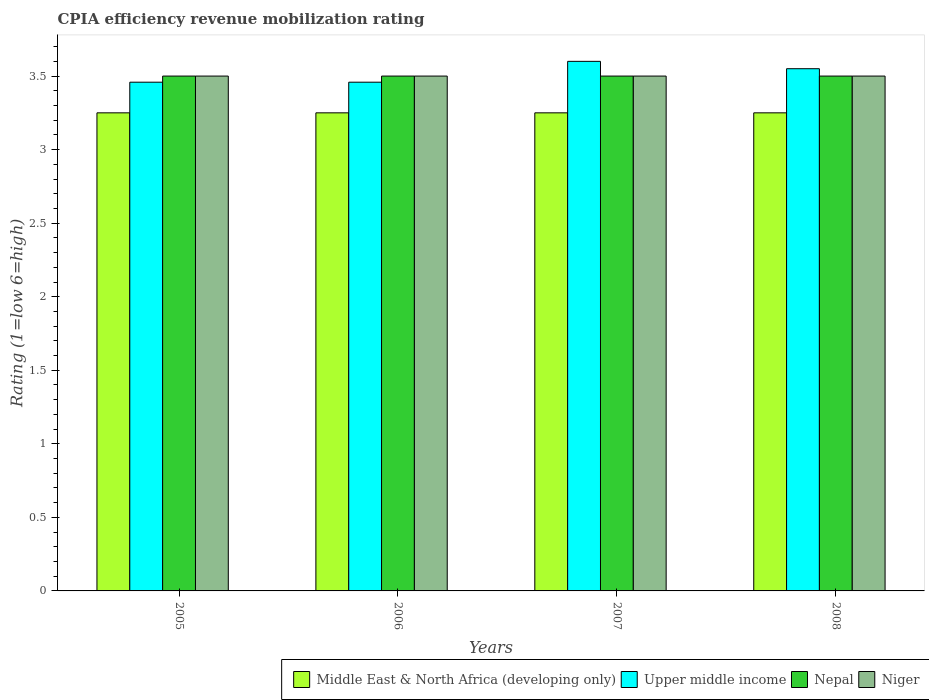How many different coloured bars are there?
Keep it short and to the point. 4. How many groups of bars are there?
Keep it short and to the point. 4. How many bars are there on the 3rd tick from the right?
Provide a short and direct response. 4. In how many cases, is the number of bars for a given year not equal to the number of legend labels?
Provide a succinct answer. 0. Across all years, what is the minimum CPIA rating in Niger?
Provide a succinct answer. 3.5. In which year was the CPIA rating in Upper middle income maximum?
Give a very brief answer. 2007. In which year was the CPIA rating in Upper middle income minimum?
Provide a short and direct response. 2005. What is the total CPIA rating in Upper middle income in the graph?
Your answer should be compact. 14.07. What is the difference between the CPIA rating in Upper middle income in 2005 and that in 2008?
Ensure brevity in your answer.  -0.09. What is the difference between the CPIA rating in Upper middle income in 2008 and the CPIA rating in Nepal in 2006?
Offer a very short reply. 0.05. What is the ratio of the CPIA rating in Nepal in 2006 to that in 2008?
Your answer should be compact. 1. What is the difference between the highest and the second highest CPIA rating in Niger?
Offer a very short reply. 0. In how many years, is the CPIA rating in Upper middle income greater than the average CPIA rating in Upper middle income taken over all years?
Give a very brief answer. 2. Is the sum of the CPIA rating in Upper middle income in 2005 and 2007 greater than the maximum CPIA rating in Nepal across all years?
Ensure brevity in your answer.  Yes. Is it the case that in every year, the sum of the CPIA rating in Middle East & North Africa (developing only) and CPIA rating in Nepal is greater than the sum of CPIA rating in Upper middle income and CPIA rating in Niger?
Offer a terse response. Yes. What does the 3rd bar from the left in 2006 represents?
Your answer should be compact. Nepal. What does the 4th bar from the right in 2008 represents?
Your response must be concise. Middle East & North Africa (developing only). Is it the case that in every year, the sum of the CPIA rating in Middle East & North Africa (developing only) and CPIA rating in Nepal is greater than the CPIA rating in Upper middle income?
Provide a succinct answer. Yes. How many years are there in the graph?
Ensure brevity in your answer.  4. Are the values on the major ticks of Y-axis written in scientific E-notation?
Your answer should be very brief. No. Does the graph contain any zero values?
Your response must be concise. No. How are the legend labels stacked?
Keep it short and to the point. Horizontal. What is the title of the graph?
Your response must be concise. CPIA efficiency revenue mobilization rating. What is the label or title of the Y-axis?
Your answer should be very brief. Rating (1=low 6=high). What is the Rating (1=low 6=high) of Middle East & North Africa (developing only) in 2005?
Provide a succinct answer. 3.25. What is the Rating (1=low 6=high) in Upper middle income in 2005?
Keep it short and to the point. 3.46. What is the Rating (1=low 6=high) in Nepal in 2005?
Your answer should be compact. 3.5. What is the Rating (1=low 6=high) of Niger in 2005?
Your answer should be compact. 3.5. What is the Rating (1=low 6=high) in Middle East & North Africa (developing only) in 2006?
Keep it short and to the point. 3.25. What is the Rating (1=low 6=high) in Upper middle income in 2006?
Give a very brief answer. 3.46. What is the Rating (1=low 6=high) in Middle East & North Africa (developing only) in 2007?
Make the answer very short. 3.25. What is the Rating (1=low 6=high) in Nepal in 2007?
Offer a very short reply. 3.5. What is the Rating (1=low 6=high) in Middle East & North Africa (developing only) in 2008?
Offer a very short reply. 3.25. What is the Rating (1=low 6=high) in Upper middle income in 2008?
Keep it short and to the point. 3.55. What is the Rating (1=low 6=high) in Nepal in 2008?
Make the answer very short. 3.5. What is the Rating (1=low 6=high) of Niger in 2008?
Give a very brief answer. 3.5. Across all years, what is the maximum Rating (1=low 6=high) in Middle East & North Africa (developing only)?
Offer a very short reply. 3.25. Across all years, what is the maximum Rating (1=low 6=high) of Upper middle income?
Provide a short and direct response. 3.6. Across all years, what is the minimum Rating (1=low 6=high) in Middle East & North Africa (developing only)?
Give a very brief answer. 3.25. Across all years, what is the minimum Rating (1=low 6=high) of Upper middle income?
Your answer should be very brief. 3.46. What is the total Rating (1=low 6=high) of Middle East & North Africa (developing only) in the graph?
Provide a succinct answer. 13. What is the total Rating (1=low 6=high) of Upper middle income in the graph?
Your answer should be very brief. 14.07. What is the total Rating (1=low 6=high) of Nepal in the graph?
Ensure brevity in your answer.  14. What is the total Rating (1=low 6=high) of Niger in the graph?
Provide a short and direct response. 14. What is the difference between the Rating (1=low 6=high) of Upper middle income in 2005 and that in 2006?
Your response must be concise. 0. What is the difference between the Rating (1=low 6=high) in Niger in 2005 and that in 2006?
Provide a short and direct response. 0. What is the difference between the Rating (1=low 6=high) in Middle East & North Africa (developing only) in 2005 and that in 2007?
Your answer should be compact. 0. What is the difference between the Rating (1=low 6=high) in Upper middle income in 2005 and that in 2007?
Your answer should be very brief. -0.14. What is the difference between the Rating (1=low 6=high) in Nepal in 2005 and that in 2007?
Provide a short and direct response. 0. What is the difference between the Rating (1=low 6=high) of Niger in 2005 and that in 2007?
Ensure brevity in your answer.  0. What is the difference between the Rating (1=low 6=high) of Middle East & North Africa (developing only) in 2005 and that in 2008?
Make the answer very short. 0. What is the difference between the Rating (1=low 6=high) in Upper middle income in 2005 and that in 2008?
Your answer should be very brief. -0.09. What is the difference between the Rating (1=low 6=high) in Niger in 2005 and that in 2008?
Your answer should be very brief. 0. What is the difference between the Rating (1=low 6=high) in Upper middle income in 2006 and that in 2007?
Ensure brevity in your answer.  -0.14. What is the difference between the Rating (1=low 6=high) of Nepal in 2006 and that in 2007?
Make the answer very short. 0. What is the difference between the Rating (1=low 6=high) of Niger in 2006 and that in 2007?
Your answer should be compact. 0. What is the difference between the Rating (1=low 6=high) of Upper middle income in 2006 and that in 2008?
Keep it short and to the point. -0.09. What is the difference between the Rating (1=low 6=high) in Nepal in 2007 and that in 2008?
Offer a very short reply. 0. What is the difference between the Rating (1=low 6=high) in Niger in 2007 and that in 2008?
Offer a terse response. 0. What is the difference between the Rating (1=low 6=high) in Middle East & North Africa (developing only) in 2005 and the Rating (1=low 6=high) in Upper middle income in 2006?
Your response must be concise. -0.21. What is the difference between the Rating (1=low 6=high) in Upper middle income in 2005 and the Rating (1=low 6=high) in Nepal in 2006?
Offer a terse response. -0.04. What is the difference between the Rating (1=low 6=high) of Upper middle income in 2005 and the Rating (1=low 6=high) of Niger in 2006?
Provide a short and direct response. -0.04. What is the difference between the Rating (1=low 6=high) in Middle East & North Africa (developing only) in 2005 and the Rating (1=low 6=high) in Upper middle income in 2007?
Provide a succinct answer. -0.35. What is the difference between the Rating (1=low 6=high) in Upper middle income in 2005 and the Rating (1=low 6=high) in Nepal in 2007?
Your response must be concise. -0.04. What is the difference between the Rating (1=low 6=high) in Upper middle income in 2005 and the Rating (1=low 6=high) in Niger in 2007?
Offer a terse response. -0.04. What is the difference between the Rating (1=low 6=high) in Middle East & North Africa (developing only) in 2005 and the Rating (1=low 6=high) in Nepal in 2008?
Give a very brief answer. -0.25. What is the difference between the Rating (1=low 6=high) of Upper middle income in 2005 and the Rating (1=low 6=high) of Nepal in 2008?
Your answer should be compact. -0.04. What is the difference between the Rating (1=low 6=high) of Upper middle income in 2005 and the Rating (1=low 6=high) of Niger in 2008?
Keep it short and to the point. -0.04. What is the difference between the Rating (1=low 6=high) of Middle East & North Africa (developing only) in 2006 and the Rating (1=low 6=high) of Upper middle income in 2007?
Ensure brevity in your answer.  -0.35. What is the difference between the Rating (1=low 6=high) of Middle East & North Africa (developing only) in 2006 and the Rating (1=low 6=high) of Nepal in 2007?
Provide a short and direct response. -0.25. What is the difference between the Rating (1=low 6=high) of Upper middle income in 2006 and the Rating (1=low 6=high) of Nepal in 2007?
Make the answer very short. -0.04. What is the difference between the Rating (1=low 6=high) in Upper middle income in 2006 and the Rating (1=low 6=high) in Niger in 2007?
Ensure brevity in your answer.  -0.04. What is the difference between the Rating (1=low 6=high) of Middle East & North Africa (developing only) in 2006 and the Rating (1=low 6=high) of Niger in 2008?
Your answer should be compact. -0.25. What is the difference between the Rating (1=low 6=high) of Upper middle income in 2006 and the Rating (1=low 6=high) of Nepal in 2008?
Ensure brevity in your answer.  -0.04. What is the difference between the Rating (1=low 6=high) in Upper middle income in 2006 and the Rating (1=low 6=high) in Niger in 2008?
Keep it short and to the point. -0.04. What is the difference between the Rating (1=low 6=high) in Middle East & North Africa (developing only) in 2007 and the Rating (1=low 6=high) in Upper middle income in 2008?
Offer a terse response. -0.3. What is the difference between the Rating (1=low 6=high) of Middle East & North Africa (developing only) in 2007 and the Rating (1=low 6=high) of Nepal in 2008?
Keep it short and to the point. -0.25. What is the difference between the Rating (1=low 6=high) of Middle East & North Africa (developing only) in 2007 and the Rating (1=low 6=high) of Niger in 2008?
Your answer should be compact. -0.25. What is the difference between the Rating (1=low 6=high) in Upper middle income in 2007 and the Rating (1=low 6=high) in Nepal in 2008?
Your response must be concise. 0.1. What is the average Rating (1=low 6=high) of Middle East & North Africa (developing only) per year?
Your answer should be very brief. 3.25. What is the average Rating (1=low 6=high) of Upper middle income per year?
Offer a terse response. 3.52. What is the average Rating (1=low 6=high) of Niger per year?
Your answer should be compact. 3.5. In the year 2005, what is the difference between the Rating (1=low 6=high) in Middle East & North Africa (developing only) and Rating (1=low 6=high) in Upper middle income?
Your response must be concise. -0.21. In the year 2005, what is the difference between the Rating (1=low 6=high) of Upper middle income and Rating (1=low 6=high) of Nepal?
Offer a very short reply. -0.04. In the year 2005, what is the difference between the Rating (1=low 6=high) in Upper middle income and Rating (1=low 6=high) in Niger?
Your answer should be compact. -0.04. In the year 2005, what is the difference between the Rating (1=low 6=high) in Nepal and Rating (1=low 6=high) in Niger?
Keep it short and to the point. 0. In the year 2006, what is the difference between the Rating (1=low 6=high) in Middle East & North Africa (developing only) and Rating (1=low 6=high) in Upper middle income?
Provide a short and direct response. -0.21. In the year 2006, what is the difference between the Rating (1=low 6=high) of Middle East & North Africa (developing only) and Rating (1=low 6=high) of Nepal?
Offer a very short reply. -0.25. In the year 2006, what is the difference between the Rating (1=low 6=high) of Upper middle income and Rating (1=low 6=high) of Nepal?
Your answer should be very brief. -0.04. In the year 2006, what is the difference between the Rating (1=low 6=high) in Upper middle income and Rating (1=low 6=high) in Niger?
Ensure brevity in your answer.  -0.04. In the year 2006, what is the difference between the Rating (1=low 6=high) in Nepal and Rating (1=low 6=high) in Niger?
Offer a terse response. 0. In the year 2007, what is the difference between the Rating (1=low 6=high) in Middle East & North Africa (developing only) and Rating (1=low 6=high) in Upper middle income?
Offer a very short reply. -0.35. In the year 2007, what is the difference between the Rating (1=low 6=high) in Upper middle income and Rating (1=low 6=high) in Nepal?
Offer a very short reply. 0.1. In the year 2007, what is the difference between the Rating (1=low 6=high) of Upper middle income and Rating (1=low 6=high) of Niger?
Your answer should be very brief. 0.1. In the year 2007, what is the difference between the Rating (1=low 6=high) of Nepal and Rating (1=low 6=high) of Niger?
Make the answer very short. 0. In the year 2008, what is the difference between the Rating (1=low 6=high) of Middle East & North Africa (developing only) and Rating (1=low 6=high) of Niger?
Ensure brevity in your answer.  -0.25. In the year 2008, what is the difference between the Rating (1=low 6=high) in Upper middle income and Rating (1=low 6=high) in Nepal?
Provide a succinct answer. 0.05. In the year 2008, what is the difference between the Rating (1=low 6=high) in Nepal and Rating (1=low 6=high) in Niger?
Give a very brief answer. 0. What is the ratio of the Rating (1=low 6=high) in Middle East & North Africa (developing only) in 2005 to that in 2006?
Keep it short and to the point. 1. What is the ratio of the Rating (1=low 6=high) of Niger in 2005 to that in 2006?
Keep it short and to the point. 1. What is the ratio of the Rating (1=low 6=high) of Upper middle income in 2005 to that in 2007?
Provide a short and direct response. 0.96. What is the ratio of the Rating (1=low 6=high) of Nepal in 2005 to that in 2007?
Offer a terse response. 1. What is the ratio of the Rating (1=low 6=high) in Niger in 2005 to that in 2007?
Offer a very short reply. 1. What is the ratio of the Rating (1=low 6=high) of Upper middle income in 2005 to that in 2008?
Offer a very short reply. 0.97. What is the ratio of the Rating (1=low 6=high) in Nepal in 2005 to that in 2008?
Provide a short and direct response. 1. What is the ratio of the Rating (1=low 6=high) of Upper middle income in 2006 to that in 2007?
Ensure brevity in your answer.  0.96. What is the ratio of the Rating (1=low 6=high) in Nepal in 2006 to that in 2007?
Keep it short and to the point. 1. What is the ratio of the Rating (1=low 6=high) of Middle East & North Africa (developing only) in 2006 to that in 2008?
Make the answer very short. 1. What is the ratio of the Rating (1=low 6=high) of Upper middle income in 2006 to that in 2008?
Provide a short and direct response. 0.97. What is the ratio of the Rating (1=low 6=high) of Middle East & North Africa (developing only) in 2007 to that in 2008?
Make the answer very short. 1. What is the ratio of the Rating (1=low 6=high) of Upper middle income in 2007 to that in 2008?
Keep it short and to the point. 1.01. What is the ratio of the Rating (1=low 6=high) in Nepal in 2007 to that in 2008?
Your answer should be compact. 1. What is the ratio of the Rating (1=low 6=high) in Niger in 2007 to that in 2008?
Provide a short and direct response. 1. What is the difference between the highest and the second highest Rating (1=low 6=high) in Nepal?
Offer a very short reply. 0. What is the difference between the highest and the second highest Rating (1=low 6=high) of Niger?
Offer a terse response. 0. What is the difference between the highest and the lowest Rating (1=low 6=high) of Middle East & North Africa (developing only)?
Your response must be concise. 0. What is the difference between the highest and the lowest Rating (1=low 6=high) in Upper middle income?
Ensure brevity in your answer.  0.14. What is the difference between the highest and the lowest Rating (1=low 6=high) in Nepal?
Keep it short and to the point. 0. 